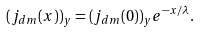<formula> <loc_0><loc_0><loc_500><loc_500>( j _ { d m } ( x ) ) _ { y } = ( j _ { d m } ( 0 ) ) _ { y } e ^ { - x / \lambda } .</formula> 